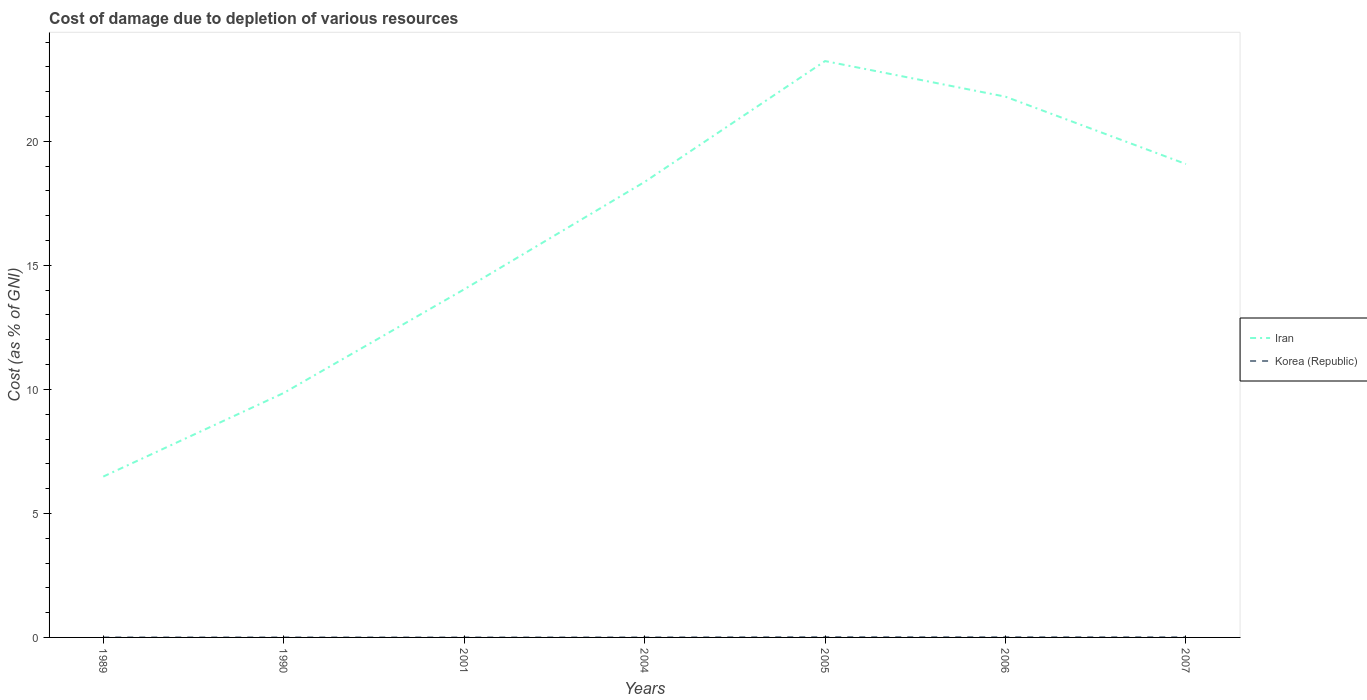How many different coloured lines are there?
Offer a terse response. 2. Does the line corresponding to Korea (Republic) intersect with the line corresponding to Iran?
Offer a terse response. No. Is the number of lines equal to the number of legend labels?
Your answer should be compact. Yes. Across all years, what is the maximum cost of damage caused due to the depletion of various resources in Korea (Republic)?
Give a very brief answer. 0. In which year was the cost of damage caused due to the depletion of various resources in Korea (Republic) maximum?
Provide a short and direct response. 2001. What is the total cost of damage caused due to the depletion of various resources in Korea (Republic) in the graph?
Make the answer very short. -0.01. What is the difference between the highest and the second highest cost of damage caused due to the depletion of various resources in Iran?
Make the answer very short. 16.75. Is the cost of damage caused due to the depletion of various resources in Iran strictly greater than the cost of damage caused due to the depletion of various resources in Korea (Republic) over the years?
Your answer should be compact. No. How many years are there in the graph?
Your answer should be compact. 7. What is the difference between two consecutive major ticks on the Y-axis?
Make the answer very short. 5. Are the values on the major ticks of Y-axis written in scientific E-notation?
Offer a very short reply. No. Does the graph contain any zero values?
Ensure brevity in your answer.  No. Does the graph contain grids?
Offer a terse response. No. Where does the legend appear in the graph?
Ensure brevity in your answer.  Center right. How many legend labels are there?
Offer a very short reply. 2. How are the legend labels stacked?
Provide a short and direct response. Vertical. What is the title of the graph?
Keep it short and to the point. Cost of damage due to depletion of various resources. Does "Paraguay" appear as one of the legend labels in the graph?
Offer a terse response. No. What is the label or title of the Y-axis?
Provide a short and direct response. Cost (as % of GNI). What is the Cost (as % of GNI) in Iran in 1989?
Your response must be concise. 6.48. What is the Cost (as % of GNI) in Korea (Republic) in 1989?
Keep it short and to the point. 0. What is the Cost (as % of GNI) in Iran in 1990?
Provide a short and direct response. 9.86. What is the Cost (as % of GNI) in Korea (Republic) in 1990?
Provide a short and direct response. 0. What is the Cost (as % of GNI) in Iran in 2001?
Your answer should be very brief. 14.03. What is the Cost (as % of GNI) in Korea (Republic) in 2001?
Make the answer very short. 0. What is the Cost (as % of GNI) in Iran in 2004?
Provide a short and direct response. 18.37. What is the Cost (as % of GNI) of Korea (Republic) in 2004?
Provide a short and direct response. 0. What is the Cost (as % of GNI) in Iran in 2005?
Ensure brevity in your answer.  23.24. What is the Cost (as % of GNI) in Korea (Republic) in 2005?
Keep it short and to the point. 0.02. What is the Cost (as % of GNI) of Iran in 2006?
Your answer should be compact. 21.8. What is the Cost (as % of GNI) in Korea (Republic) in 2006?
Offer a terse response. 0.01. What is the Cost (as % of GNI) of Iran in 2007?
Ensure brevity in your answer.  19.09. What is the Cost (as % of GNI) of Korea (Republic) in 2007?
Keep it short and to the point. 0.01. Across all years, what is the maximum Cost (as % of GNI) of Iran?
Provide a succinct answer. 23.24. Across all years, what is the maximum Cost (as % of GNI) in Korea (Republic)?
Keep it short and to the point. 0.02. Across all years, what is the minimum Cost (as % of GNI) in Iran?
Give a very brief answer. 6.48. Across all years, what is the minimum Cost (as % of GNI) of Korea (Republic)?
Offer a terse response. 0. What is the total Cost (as % of GNI) in Iran in the graph?
Ensure brevity in your answer.  112.87. What is the total Cost (as % of GNI) of Korea (Republic) in the graph?
Give a very brief answer. 0.05. What is the difference between the Cost (as % of GNI) of Iran in 1989 and that in 1990?
Your answer should be very brief. -3.37. What is the difference between the Cost (as % of GNI) of Korea (Republic) in 1989 and that in 1990?
Your answer should be compact. -0. What is the difference between the Cost (as % of GNI) in Iran in 1989 and that in 2001?
Offer a very short reply. -7.55. What is the difference between the Cost (as % of GNI) of Korea (Republic) in 1989 and that in 2001?
Offer a very short reply. 0. What is the difference between the Cost (as % of GNI) of Iran in 1989 and that in 2004?
Offer a very short reply. -11.88. What is the difference between the Cost (as % of GNI) in Korea (Republic) in 1989 and that in 2004?
Your answer should be very brief. -0. What is the difference between the Cost (as % of GNI) of Iran in 1989 and that in 2005?
Offer a terse response. -16.75. What is the difference between the Cost (as % of GNI) in Korea (Republic) in 1989 and that in 2005?
Your response must be concise. -0.01. What is the difference between the Cost (as % of GNI) of Iran in 1989 and that in 2006?
Give a very brief answer. -15.32. What is the difference between the Cost (as % of GNI) of Korea (Republic) in 1989 and that in 2006?
Ensure brevity in your answer.  -0.01. What is the difference between the Cost (as % of GNI) in Iran in 1989 and that in 2007?
Your answer should be very brief. -12.6. What is the difference between the Cost (as % of GNI) of Korea (Republic) in 1989 and that in 2007?
Give a very brief answer. -0.01. What is the difference between the Cost (as % of GNI) of Iran in 1990 and that in 2001?
Offer a very short reply. -4.18. What is the difference between the Cost (as % of GNI) in Korea (Republic) in 1990 and that in 2001?
Provide a succinct answer. 0. What is the difference between the Cost (as % of GNI) in Iran in 1990 and that in 2004?
Offer a terse response. -8.51. What is the difference between the Cost (as % of GNI) in Korea (Republic) in 1990 and that in 2004?
Offer a terse response. -0. What is the difference between the Cost (as % of GNI) of Iran in 1990 and that in 2005?
Provide a succinct answer. -13.38. What is the difference between the Cost (as % of GNI) in Korea (Republic) in 1990 and that in 2005?
Ensure brevity in your answer.  -0.01. What is the difference between the Cost (as % of GNI) in Iran in 1990 and that in 2006?
Make the answer very short. -11.95. What is the difference between the Cost (as % of GNI) of Korea (Republic) in 1990 and that in 2006?
Your answer should be very brief. -0.01. What is the difference between the Cost (as % of GNI) in Iran in 1990 and that in 2007?
Your response must be concise. -9.23. What is the difference between the Cost (as % of GNI) of Korea (Republic) in 1990 and that in 2007?
Ensure brevity in your answer.  -0.01. What is the difference between the Cost (as % of GNI) of Iran in 2001 and that in 2004?
Offer a very short reply. -4.33. What is the difference between the Cost (as % of GNI) in Korea (Republic) in 2001 and that in 2004?
Ensure brevity in your answer.  -0. What is the difference between the Cost (as % of GNI) of Iran in 2001 and that in 2005?
Make the answer very short. -9.2. What is the difference between the Cost (as % of GNI) of Korea (Republic) in 2001 and that in 2005?
Keep it short and to the point. -0.01. What is the difference between the Cost (as % of GNI) in Iran in 2001 and that in 2006?
Offer a very short reply. -7.77. What is the difference between the Cost (as % of GNI) of Korea (Republic) in 2001 and that in 2006?
Make the answer very short. -0.01. What is the difference between the Cost (as % of GNI) of Iran in 2001 and that in 2007?
Provide a short and direct response. -5.05. What is the difference between the Cost (as % of GNI) of Korea (Republic) in 2001 and that in 2007?
Provide a short and direct response. -0.01. What is the difference between the Cost (as % of GNI) in Iran in 2004 and that in 2005?
Provide a succinct answer. -4.87. What is the difference between the Cost (as % of GNI) in Korea (Republic) in 2004 and that in 2005?
Make the answer very short. -0.01. What is the difference between the Cost (as % of GNI) in Iran in 2004 and that in 2006?
Provide a short and direct response. -3.44. What is the difference between the Cost (as % of GNI) of Korea (Republic) in 2004 and that in 2006?
Offer a terse response. -0.01. What is the difference between the Cost (as % of GNI) of Iran in 2004 and that in 2007?
Your response must be concise. -0.72. What is the difference between the Cost (as % of GNI) of Korea (Republic) in 2004 and that in 2007?
Keep it short and to the point. -0.01. What is the difference between the Cost (as % of GNI) of Iran in 2005 and that in 2006?
Provide a short and direct response. 1.44. What is the difference between the Cost (as % of GNI) in Korea (Republic) in 2005 and that in 2006?
Your answer should be compact. 0. What is the difference between the Cost (as % of GNI) in Iran in 2005 and that in 2007?
Keep it short and to the point. 4.15. What is the difference between the Cost (as % of GNI) of Korea (Republic) in 2005 and that in 2007?
Ensure brevity in your answer.  0.01. What is the difference between the Cost (as % of GNI) in Iran in 2006 and that in 2007?
Provide a succinct answer. 2.72. What is the difference between the Cost (as % of GNI) in Korea (Republic) in 2006 and that in 2007?
Your response must be concise. 0. What is the difference between the Cost (as % of GNI) of Iran in 1989 and the Cost (as % of GNI) of Korea (Republic) in 1990?
Your response must be concise. 6.48. What is the difference between the Cost (as % of GNI) of Iran in 1989 and the Cost (as % of GNI) of Korea (Republic) in 2001?
Make the answer very short. 6.48. What is the difference between the Cost (as % of GNI) of Iran in 1989 and the Cost (as % of GNI) of Korea (Republic) in 2004?
Keep it short and to the point. 6.48. What is the difference between the Cost (as % of GNI) in Iran in 1989 and the Cost (as % of GNI) in Korea (Republic) in 2005?
Offer a terse response. 6.47. What is the difference between the Cost (as % of GNI) in Iran in 1989 and the Cost (as % of GNI) in Korea (Republic) in 2006?
Your answer should be compact. 6.47. What is the difference between the Cost (as % of GNI) of Iran in 1989 and the Cost (as % of GNI) of Korea (Republic) in 2007?
Make the answer very short. 6.47. What is the difference between the Cost (as % of GNI) in Iran in 1990 and the Cost (as % of GNI) in Korea (Republic) in 2001?
Offer a terse response. 9.86. What is the difference between the Cost (as % of GNI) of Iran in 1990 and the Cost (as % of GNI) of Korea (Republic) in 2004?
Provide a short and direct response. 9.85. What is the difference between the Cost (as % of GNI) of Iran in 1990 and the Cost (as % of GNI) of Korea (Republic) in 2005?
Offer a terse response. 9.84. What is the difference between the Cost (as % of GNI) of Iran in 1990 and the Cost (as % of GNI) of Korea (Republic) in 2006?
Make the answer very short. 9.84. What is the difference between the Cost (as % of GNI) of Iran in 1990 and the Cost (as % of GNI) of Korea (Republic) in 2007?
Give a very brief answer. 9.85. What is the difference between the Cost (as % of GNI) of Iran in 2001 and the Cost (as % of GNI) of Korea (Republic) in 2004?
Give a very brief answer. 14.03. What is the difference between the Cost (as % of GNI) of Iran in 2001 and the Cost (as % of GNI) of Korea (Republic) in 2005?
Provide a succinct answer. 14.02. What is the difference between the Cost (as % of GNI) in Iran in 2001 and the Cost (as % of GNI) in Korea (Republic) in 2006?
Ensure brevity in your answer.  14.02. What is the difference between the Cost (as % of GNI) in Iran in 2001 and the Cost (as % of GNI) in Korea (Republic) in 2007?
Your answer should be very brief. 14.02. What is the difference between the Cost (as % of GNI) in Iran in 2004 and the Cost (as % of GNI) in Korea (Republic) in 2005?
Give a very brief answer. 18.35. What is the difference between the Cost (as % of GNI) in Iran in 2004 and the Cost (as % of GNI) in Korea (Republic) in 2006?
Keep it short and to the point. 18.35. What is the difference between the Cost (as % of GNI) in Iran in 2004 and the Cost (as % of GNI) in Korea (Republic) in 2007?
Give a very brief answer. 18.35. What is the difference between the Cost (as % of GNI) in Iran in 2005 and the Cost (as % of GNI) in Korea (Republic) in 2006?
Your response must be concise. 23.23. What is the difference between the Cost (as % of GNI) in Iran in 2005 and the Cost (as % of GNI) in Korea (Republic) in 2007?
Offer a terse response. 23.23. What is the difference between the Cost (as % of GNI) of Iran in 2006 and the Cost (as % of GNI) of Korea (Republic) in 2007?
Your answer should be compact. 21.79. What is the average Cost (as % of GNI) of Iran per year?
Make the answer very short. 16.12. What is the average Cost (as % of GNI) in Korea (Republic) per year?
Make the answer very short. 0.01. In the year 1989, what is the difference between the Cost (as % of GNI) in Iran and Cost (as % of GNI) in Korea (Republic)?
Keep it short and to the point. 6.48. In the year 1990, what is the difference between the Cost (as % of GNI) in Iran and Cost (as % of GNI) in Korea (Republic)?
Keep it short and to the point. 9.85. In the year 2001, what is the difference between the Cost (as % of GNI) in Iran and Cost (as % of GNI) in Korea (Republic)?
Provide a succinct answer. 14.03. In the year 2004, what is the difference between the Cost (as % of GNI) of Iran and Cost (as % of GNI) of Korea (Republic)?
Ensure brevity in your answer.  18.36. In the year 2005, what is the difference between the Cost (as % of GNI) of Iran and Cost (as % of GNI) of Korea (Republic)?
Make the answer very short. 23.22. In the year 2006, what is the difference between the Cost (as % of GNI) of Iran and Cost (as % of GNI) of Korea (Republic)?
Offer a terse response. 21.79. In the year 2007, what is the difference between the Cost (as % of GNI) of Iran and Cost (as % of GNI) of Korea (Republic)?
Your response must be concise. 19.08. What is the ratio of the Cost (as % of GNI) of Iran in 1989 to that in 1990?
Offer a terse response. 0.66. What is the ratio of the Cost (as % of GNI) of Korea (Republic) in 1989 to that in 1990?
Offer a terse response. 0.81. What is the ratio of the Cost (as % of GNI) in Iran in 1989 to that in 2001?
Offer a very short reply. 0.46. What is the ratio of the Cost (as % of GNI) of Korea (Republic) in 1989 to that in 2001?
Provide a short and direct response. 2.08. What is the ratio of the Cost (as % of GNI) in Iran in 1989 to that in 2004?
Provide a short and direct response. 0.35. What is the ratio of the Cost (as % of GNI) in Korea (Republic) in 1989 to that in 2004?
Your answer should be compact. 0.61. What is the ratio of the Cost (as % of GNI) in Iran in 1989 to that in 2005?
Offer a terse response. 0.28. What is the ratio of the Cost (as % of GNI) in Korea (Republic) in 1989 to that in 2005?
Ensure brevity in your answer.  0.15. What is the ratio of the Cost (as % of GNI) of Iran in 1989 to that in 2006?
Give a very brief answer. 0.3. What is the ratio of the Cost (as % of GNI) of Korea (Republic) in 1989 to that in 2006?
Provide a short and direct response. 0.19. What is the ratio of the Cost (as % of GNI) of Iran in 1989 to that in 2007?
Provide a succinct answer. 0.34. What is the ratio of the Cost (as % of GNI) in Korea (Republic) in 1989 to that in 2007?
Your answer should be very brief. 0.23. What is the ratio of the Cost (as % of GNI) in Iran in 1990 to that in 2001?
Provide a succinct answer. 0.7. What is the ratio of the Cost (as % of GNI) of Korea (Republic) in 1990 to that in 2001?
Provide a short and direct response. 2.58. What is the ratio of the Cost (as % of GNI) of Iran in 1990 to that in 2004?
Keep it short and to the point. 0.54. What is the ratio of the Cost (as % of GNI) of Korea (Republic) in 1990 to that in 2004?
Offer a very short reply. 0.76. What is the ratio of the Cost (as % of GNI) in Iran in 1990 to that in 2005?
Your answer should be very brief. 0.42. What is the ratio of the Cost (as % of GNI) of Korea (Republic) in 1990 to that in 2005?
Give a very brief answer. 0.19. What is the ratio of the Cost (as % of GNI) of Iran in 1990 to that in 2006?
Offer a terse response. 0.45. What is the ratio of the Cost (as % of GNI) in Korea (Republic) in 1990 to that in 2006?
Ensure brevity in your answer.  0.24. What is the ratio of the Cost (as % of GNI) of Iran in 1990 to that in 2007?
Your answer should be compact. 0.52. What is the ratio of the Cost (as % of GNI) in Korea (Republic) in 1990 to that in 2007?
Ensure brevity in your answer.  0.28. What is the ratio of the Cost (as % of GNI) of Iran in 2001 to that in 2004?
Your answer should be compact. 0.76. What is the ratio of the Cost (as % of GNI) of Korea (Republic) in 2001 to that in 2004?
Make the answer very short. 0.29. What is the ratio of the Cost (as % of GNI) of Iran in 2001 to that in 2005?
Make the answer very short. 0.6. What is the ratio of the Cost (as % of GNI) in Korea (Republic) in 2001 to that in 2005?
Make the answer very short. 0.07. What is the ratio of the Cost (as % of GNI) of Iran in 2001 to that in 2006?
Give a very brief answer. 0.64. What is the ratio of the Cost (as % of GNI) in Korea (Republic) in 2001 to that in 2006?
Offer a terse response. 0.09. What is the ratio of the Cost (as % of GNI) of Iran in 2001 to that in 2007?
Keep it short and to the point. 0.74. What is the ratio of the Cost (as % of GNI) in Korea (Republic) in 2001 to that in 2007?
Keep it short and to the point. 0.11. What is the ratio of the Cost (as % of GNI) of Iran in 2004 to that in 2005?
Provide a succinct answer. 0.79. What is the ratio of the Cost (as % of GNI) of Korea (Republic) in 2004 to that in 2005?
Your answer should be very brief. 0.25. What is the ratio of the Cost (as % of GNI) of Iran in 2004 to that in 2006?
Provide a short and direct response. 0.84. What is the ratio of the Cost (as % of GNI) of Korea (Republic) in 2004 to that in 2006?
Your response must be concise. 0.31. What is the ratio of the Cost (as % of GNI) in Iran in 2004 to that in 2007?
Give a very brief answer. 0.96. What is the ratio of the Cost (as % of GNI) of Korea (Republic) in 2004 to that in 2007?
Give a very brief answer. 0.37. What is the ratio of the Cost (as % of GNI) in Iran in 2005 to that in 2006?
Your answer should be very brief. 1.07. What is the ratio of the Cost (as % of GNI) of Korea (Republic) in 2005 to that in 2006?
Offer a very short reply. 1.26. What is the ratio of the Cost (as % of GNI) of Iran in 2005 to that in 2007?
Offer a terse response. 1.22. What is the ratio of the Cost (as % of GNI) in Korea (Republic) in 2005 to that in 2007?
Offer a very short reply. 1.49. What is the ratio of the Cost (as % of GNI) in Iran in 2006 to that in 2007?
Your response must be concise. 1.14. What is the ratio of the Cost (as % of GNI) of Korea (Republic) in 2006 to that in 2007?
Your answer should be compact. 1.18. What is the difference between the highest and the second highest Cost (as % of GNI) in Iran?
Provide a succinct answer. 1.44. What is the difference between the highest and the second highest Cost (as % of GNI) of Korea (Republic)?
Provide a succinct answer. 0. What is the difference between the highest and the lowest Cost (as % of GNI) in Iran?
Offer a very short reply. 16.75. What is the difference between the highest and the lowest Cost (as % of GNI) in Korea (Republic)?
Provide a succinct answer. 0.01. 